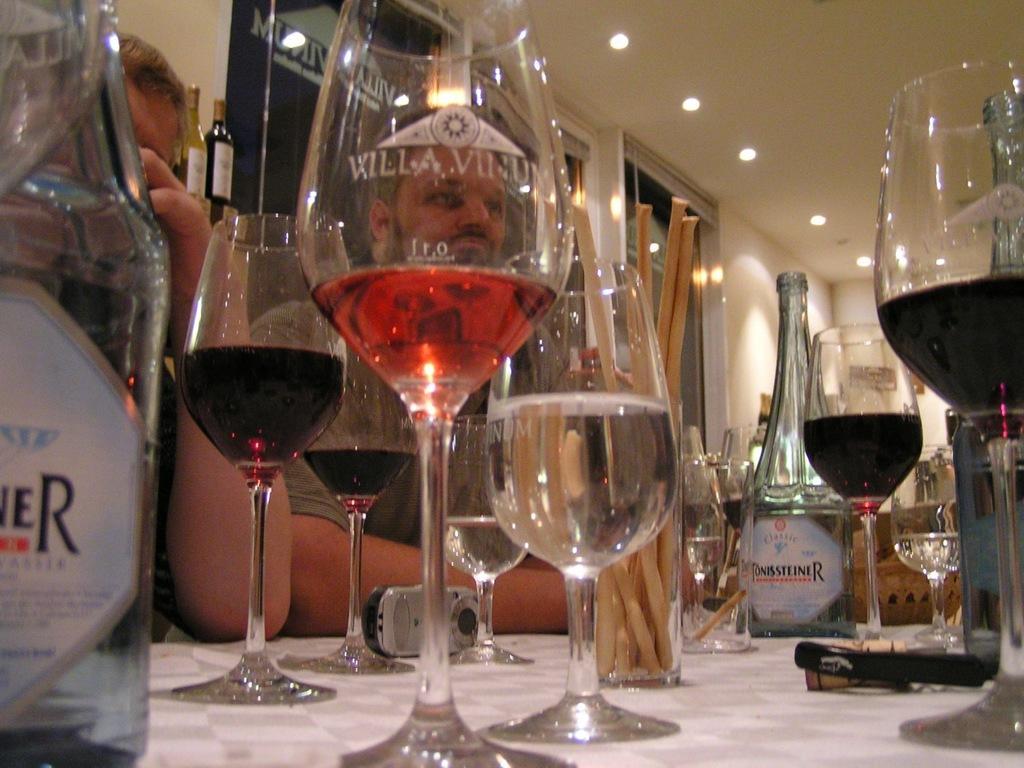Please provide a concise description of this image. This picture is clicked inside. In the foreground there is a white color table on the top of which bottles and glasses of drinks are placed and we can see a mobile phone and some other items are placed on the top of the table. On the left there are two persons seems to be sitting on the chairs. In the background there is a roof, ceiling lights, windows, window blinds, wall and many other objects. 